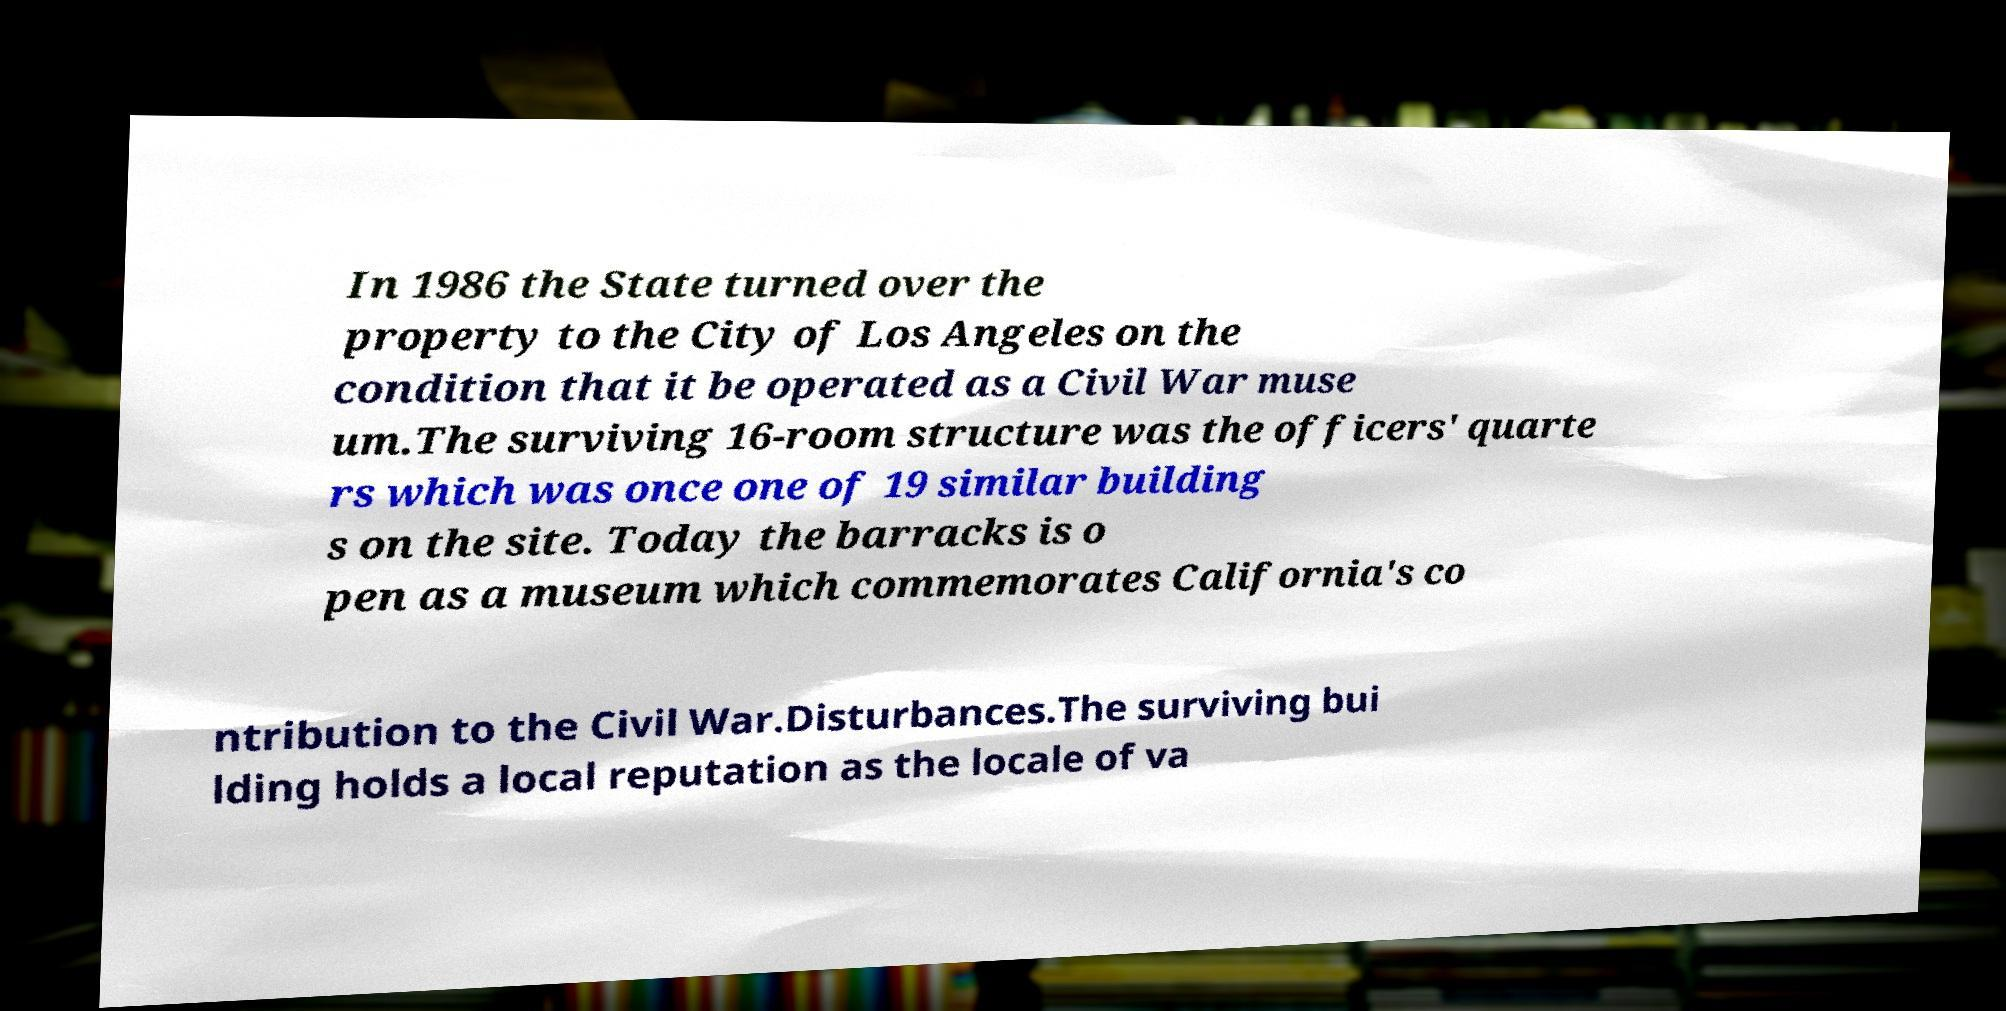What messages or text are displayed in this image? I need them in a readable, typed format. In 1986 the State turned over the property to the City of Los Angeles on the condition that it be operated as a Civil War muse um.The surviving 16-room structure was the officers' quarte rs which was once one of 19 similar building s on the site. Today the barracks is o pen as a museum which commemorates California's co ntribution to the Civil War.Disturbances.The surviving bui lding holds a local reputation as the locale of va 